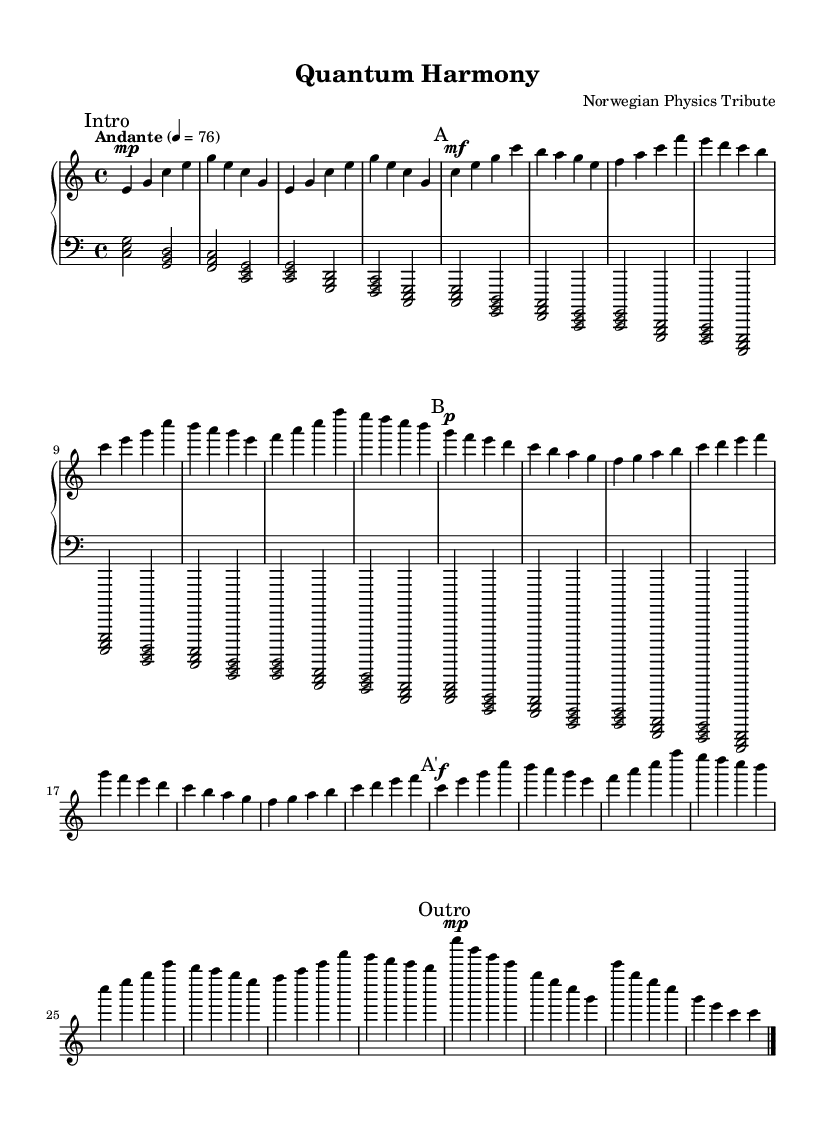What is the key signature of this music? The key signature is C major, which has no sharps or flats.
Answer: C major What is the time signature of this music? The time signature is found at the beginning of the score, indicating that the music is in 4/4 time.
Answer: 4/4 What is the tempo marking of this piece? The tempo marking, listed after the time signature, indicates "Andante" with a metronome marking of 76 beats per minute.
Answer: Andante, 76 How many sections are there in this piece? The music is structured into four distinct sections: Intro, Section A, Section B, and Outro, which can be identified by the markings in the score.
Answer: Four What dynamic marking is used at the beginning of Section B? The marking indicates it is played piano, as shown by the "p" notation at the start of Section B.
Answer: Piano Which melodic idea is repeated in Section A and A'? The melodic idea from Section A is repeated in A' with the same notes and rhythm, thus creating a thematic unity in the composition.
Answer: Same theme What is the highest note in the right-hand part? By examining the right-hand staff, the highest note is e, found at the start of the introductory section.
Answer: E 